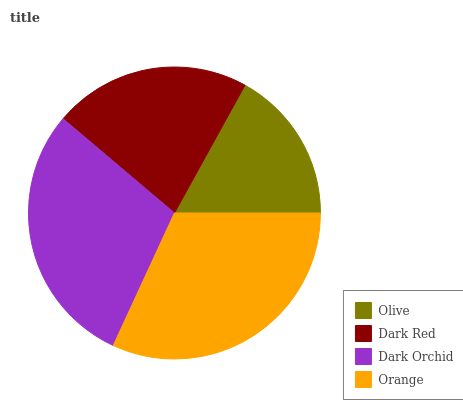Is Olive the minimum?
Answer yes or no. Yes. Is Orange the maximum?
Answer yes or no. Yes. Is Dark Red the minimum?
Answer yes or no. No. Is Dark Red the maximum?
Answer yes or no. No. Is Dark Red greater than Olive?
Answer yes or no. Yes. Is Olive less than Dark Red?
Answer yes or no. Yes. Is Olive greater than Dark Red?
Answer yes or no. No. Is Dark Red less than Olive?
Answer yes or no. No. Is Dark Orchid the high median?
Answer yes or no. Yes. Is Dark Red the low median?
Answer yes or no. Yes. Is Olive the high median?
Answer yes or no. No. Is Dark Orchid the low median?
Answer yes or no. No. 